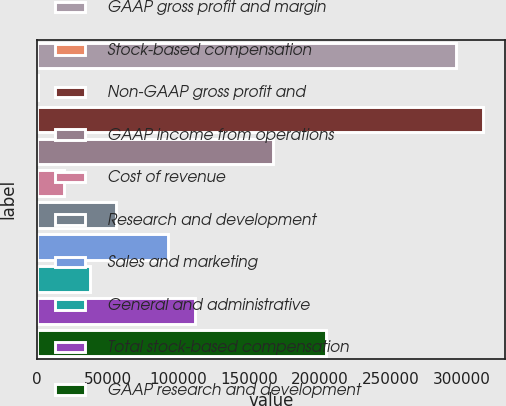Convert chart to OTSL. <chart><loc_0><loc_0><loc_500><loc_500><bar_chart><fcel>GAAP gross profit and margin<fcel>Stock-based compensation<fcel>Non-GAAP gross profit and<fcel>GAAP income from operations<fcel>Cost of revenue<fcel>Research and development<fcel>Sales and marketing<fcel>General and administrative<fcel>Total stock-based compensation<fcel>GAAP research and development<nl><fcel>296003<fcel>760<fcel>314456<fcel>166834<fcel>19212.7<fcel>56118.1<fcel>93023.5<fcel>37665.4<fcel>111476<fcel>203740<nl></chart> 